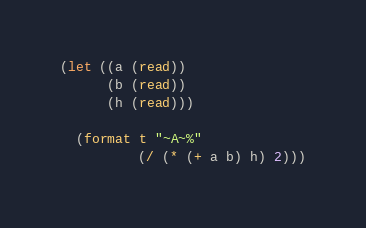Convert code to text. <code><loc_0><loc_0><loc_500><loc_500><_Lisp_>(let ((a (read))
      (b (read))
      (h (read)))

  (format t "~A~%"
          (/ (* (+ a b) h) 2)))
</code> 